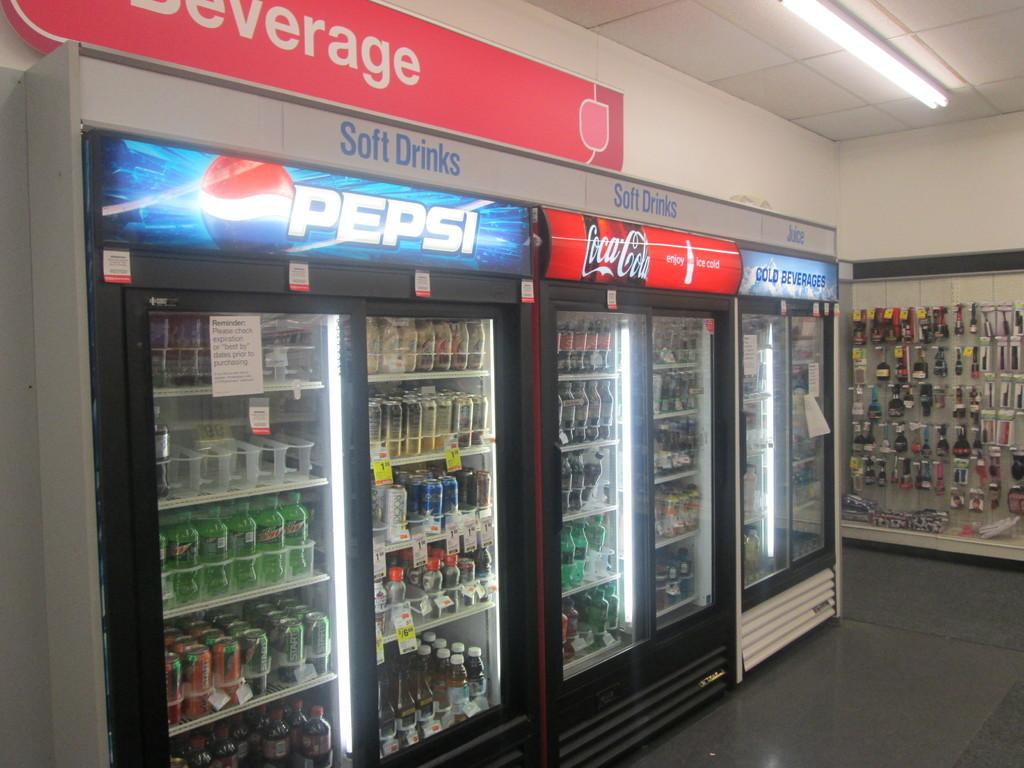<image>
Describe the image concisely. Many fridges of soft drinks including one fridge with the Pepsi logo above it. 